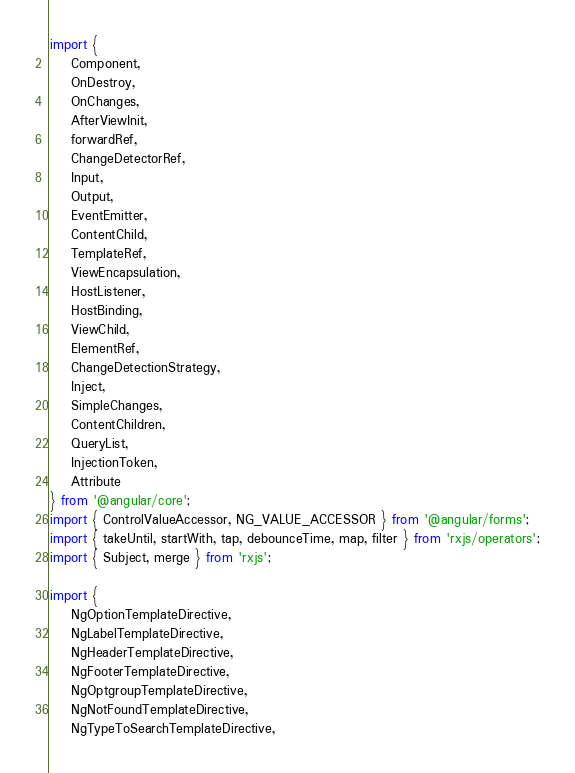<code> <loc_0><loc_0><loc_500><loc_500><_TypeScript_>import {
    Component,
    OnDestroy,
    OnChanges,
    AfterViewInit,
    forwardRef,
    ChangeDetectorRef,
    Input,
    Output,
    EventEmitter,
    ContentChild,
    TemplateRef,
    ViewEncapsulation,
    HostListener,
    HostBinding,
    ViewChild,
    ElementRef,
    ChangeDetectionStrategy,
    Inject,
    SimpleChanges,
    ContentChildren,
    QueryList,
    InjectionToken,
    Attribute
} from '@angular/core';
import { ControlValueAccessor, NG_VALUE_ACCESSOR } from '@angular/forms';
import { takeUntil, startWith, tap, debounceTime, map, filter } from 'rxjs/operators';
import { Subject, merge } from 'rxjs';

import {
    NgOptionTemplateDirective,
    NgLabelTemplateDirective,
    NgHeaderTemplateDirective,
    NgFooterTemplateDirective,
    NgOptgroupTemplateDirective,
    NgNotFoundTemplateDirective,
    NgTypeToSearchTemplateDirective,</code> 